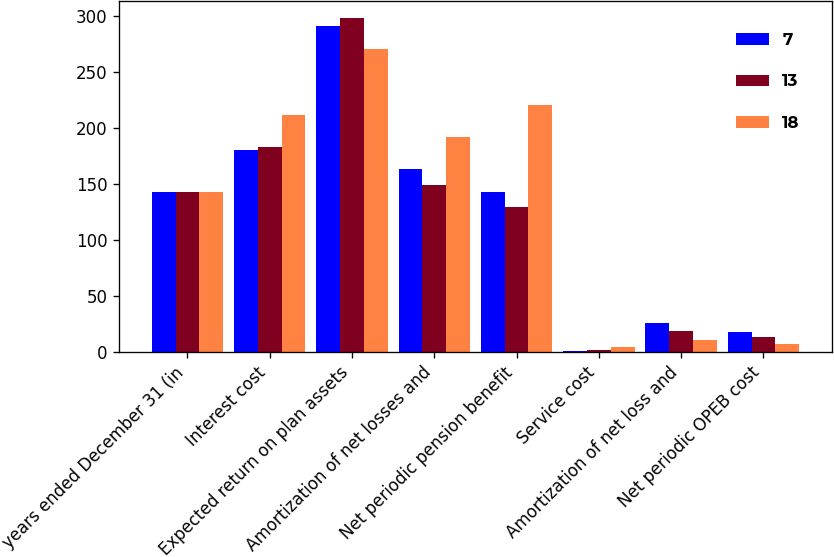Convert chart to OTSL. <chart><loc_0><loc_0><loc_500><loc_500><stacked_bar_chart><ecel><fcel>years ended December 31 (in<fcel>Interest cost<fcel>Expected return on plan assets<fcel>Amortization of net losses and<fcel>Net periodic pension benefit<fcel>Service cost<fcel>Amortization of net loss and<fcel>Net periodic OPEB cost<nl><fcel>7<fcel>143<fcel>180<fcel>291<fcel>163<fcel>143<fcel>1<fcel>26<fcel>18<nl><fcel>13<fcel>143<fcel>183<fcel>298<fcel>149<fcel>129<fcel>2<fcel>19<fcel>13<nl><fcel>18<fcel>143<fcel>211<fcel>270<fcel>192<fcel>220<fcel>4<fcel>11<fcel>7<nl></chart> 